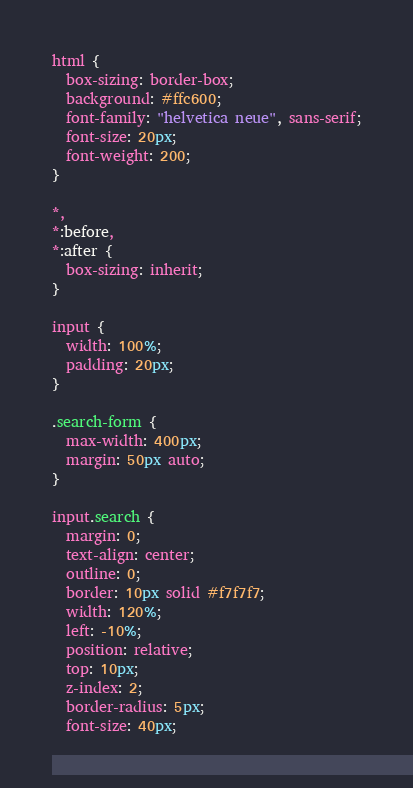<code> <loc_0><loc_0><loc_500><loc_500><_CSS_>html {
  box-sizing: border-box;
  background: #ffc600;
  font-family: "helvetica neue", sans-serif;
  font-size: 20px;
  font-weight: 200;
}

*,
*:before,
*:after {
  box-sizing: inherit;
}

input {
  width: 100%;
  padding: 20px;
}

.search-form {
  max-width: 400px;
  margin: 50px auto;
}

input.search {
  margin: 0;
  text-align: center;
  outline: 0;
  border: 10px solid #f7f7f7;
  width: 120%;
  left: -10%;
  position: relative;
  top: 10px;
  z-index: 2;
  border-radius: 5px;
  font-size: 40px;</code> 